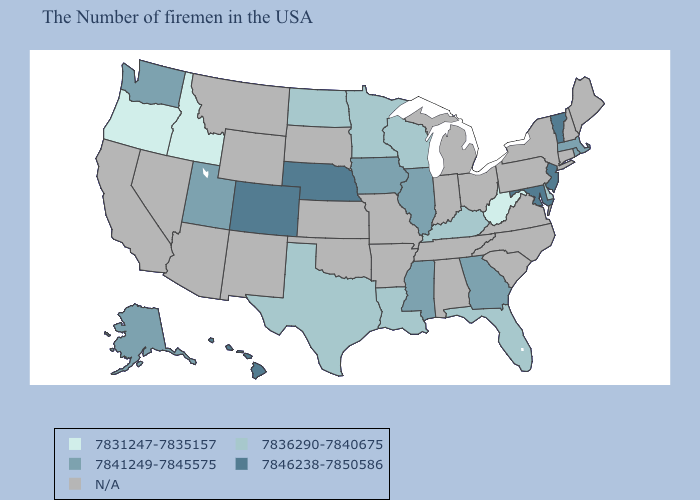Which states have the lowest value in the USA?
Concise answer only. West Virginia, Idaho, Oregon. Which states have the highest value in the USA?
Short answer required. Vermont, New Jersey, Maryland, Nebraska, Colorado, Hawaii. Name the states that have a value in the range N/A?
Give a very brief answer. Maine, New Hampshire, Connecticut, New York, Pennsylvania, Virginia, North Carolina, South Carolina, Ohio, Michigan, Indiana, Alabama, Tennessee, Missouri, Arkansas, Kansas, Oklahoma, South Dakota, Wyoming, New Mexico, Montana, Arizona, Nevada, California. What is the highest value in states that border Wisconsin?
Concise answer only. 7841249-7845575. Which states have the lowest value in the MidWest?
Keep it brief. Wisconsin, Minnesota, North Dakota. What is the highest value in the Northeast ?
Keep it brief. 7846238-7850586. Name the states that have a value in the range 7831247-7835157?
Write a very short answer. West Virginia, Idaho, Oregon. Among the states that border Washington , which have the lowest value?
Concise answer only. Idaho, Oregon. Does the first symbol in the legend represent the smallest category?
Concise answer only. Yes. What is the value of Mississippi?
Keep it brief. 7841249-7845575. What is the lowest value in the South?
Be succinct. 7831247-7835157. What is the value of Massachusetts?
Concise answer only. 7841249-7845575. What is the lowest value in the South?
Quick response, please. 7831247-7835157. What is the lowest value in the West?
Short answer required. 7831247-7835157. 